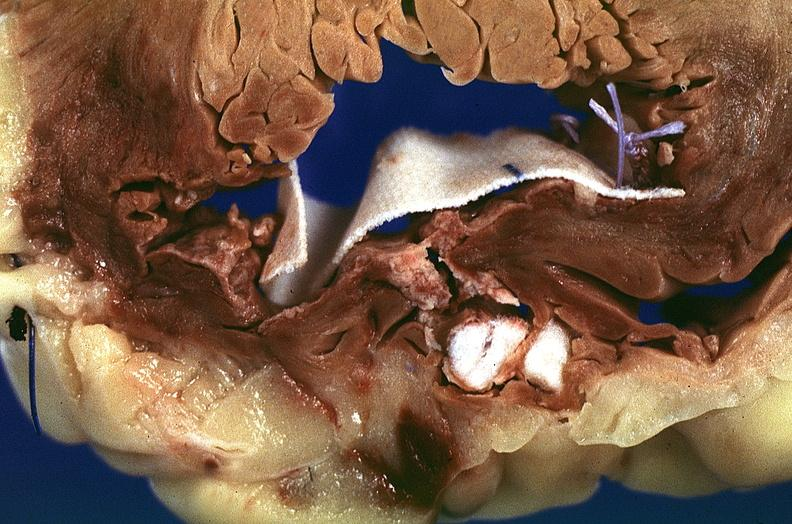does beckwith-wiedemann syndrome show heart, myocardial infarction, surgery to repair interventricular septum rupture?
Answer the question using a single word or phrase. No 